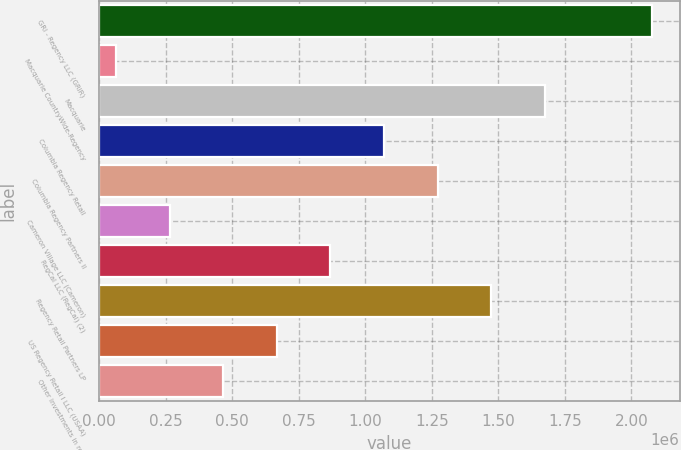<chart> <loc_0><loc_0><loc_500><loc_500><bar_chart><fcel>GRI - Regency LLC (GRIR)<fcel>Macquarie CountryWide-Regency<fcel>Macquarie<fcel>Columbia Regency Retail<fcel>Columbia Regency Partners II<fcel>Cameron Village LLC (Cameron)<fcel>RegCal LLC (RegCal) (2)<fcel>Regency Retail Partners LP<fcel>US Regency Retail I LLC (USAA)<fcel>Other investments in real<nl><fcel>2.07724e+06<fcel>63575<fcel>1.67451e+06<fcel>1.07041e+06<fcel>1.27177e+06<fcel>264942<fcel>869041<fcel>1.47314e+06<fcel>667674<fcel>466308<nl></chart> 